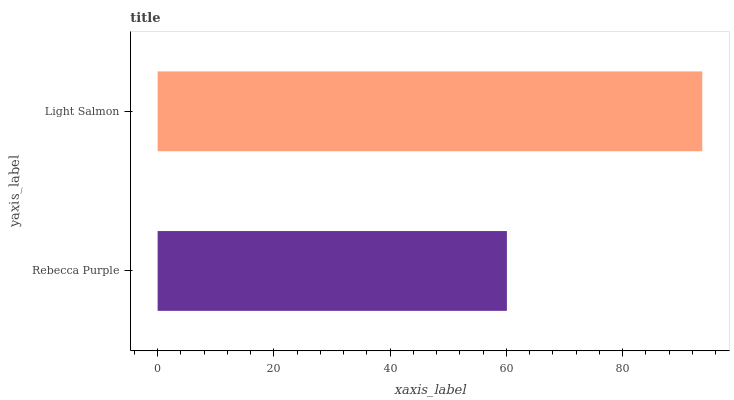Is Rebecca Purple the minimum?
Answer yes or no. Yes. Is Light Salmon the maximum?
Answer yes or no. Yes. Is Light Salmon the minimum?
Answer yes or no. No. Is Light Salmon greater than Rebecca Purple?
Answer yes or no. Yes. Is Rebecca Purple less than Light Salmon?
Answer yes or no. Yes. Is Rebecca Purple greater than Light Salmon?
Answer yes or no. No. Is Light Salmon less than Rebecca Purple?
Answer yes or no. No. Is Light Salmon the high median?
Answer yes or no. Yes. Is Rebecca Purple the low median?
Answer yes or no. Yes. Is Rebecca Purple the high median?
Answer yes or no. No. Is Light Salmon the low median?
Answer yes or no. No. 